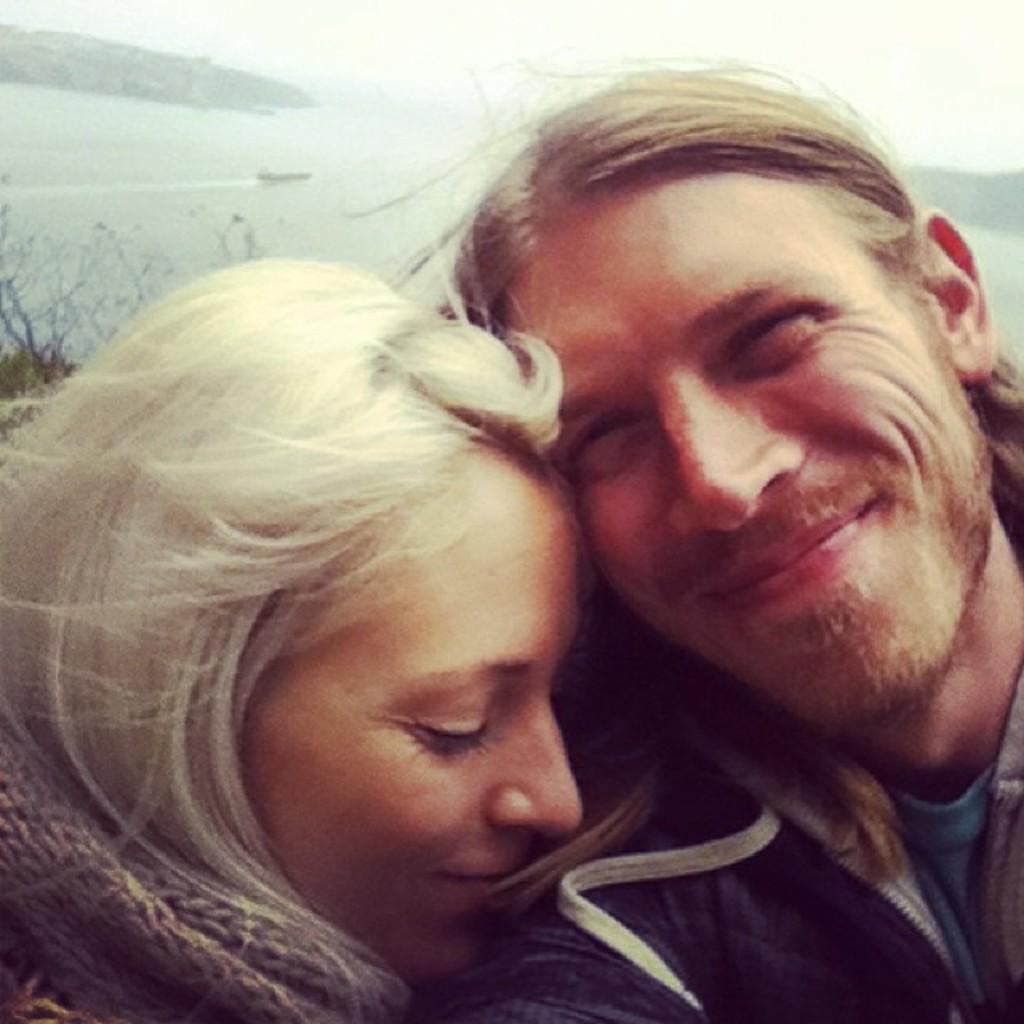How would you summarize this image in a sentence or two? In this picture I can see a man and a woman with smile on their faces and I can see plants and a boat in the water and hills on the back. 